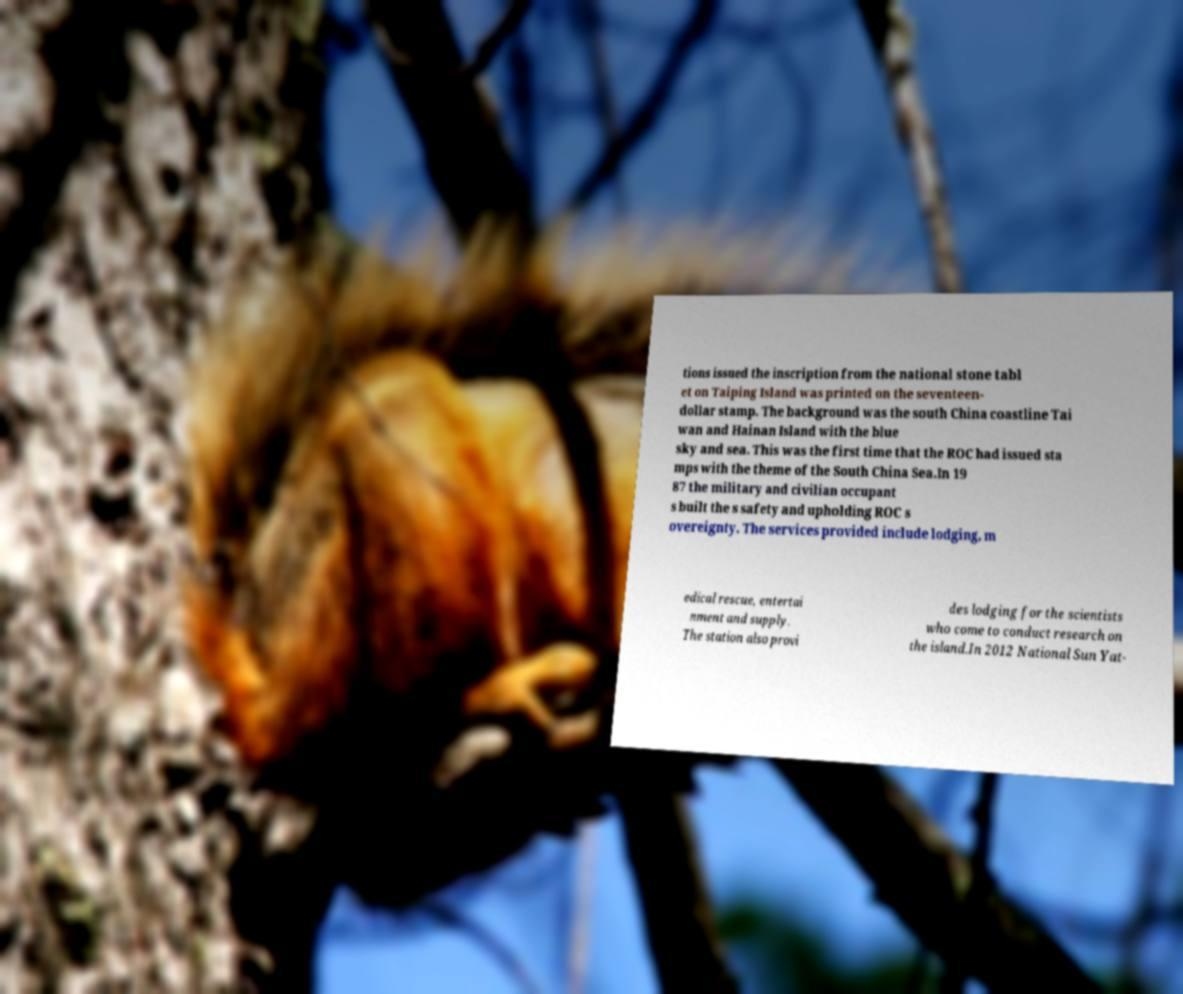What messages or text are displayed in this image? I need them in a readable, typed format. tions issued the inscription from the national stone tabl et on Taiping Island was printed on the seventeen- dollar stamp. The background was the south China coastline Tai wan and Hainan Island with the blue sky and sea. This was the first time that the ROC had issued sta mps with the theme of the South China Sea.In 19 87 the military and civilian occupant s built the s safety and upholding ROC s overeignty. The services provided include lodging, m edical rescue, entertai nment and supply. The station also provi des lodging for the scientists who come to conduct research on the island.In 2012 National Sun Yat- 